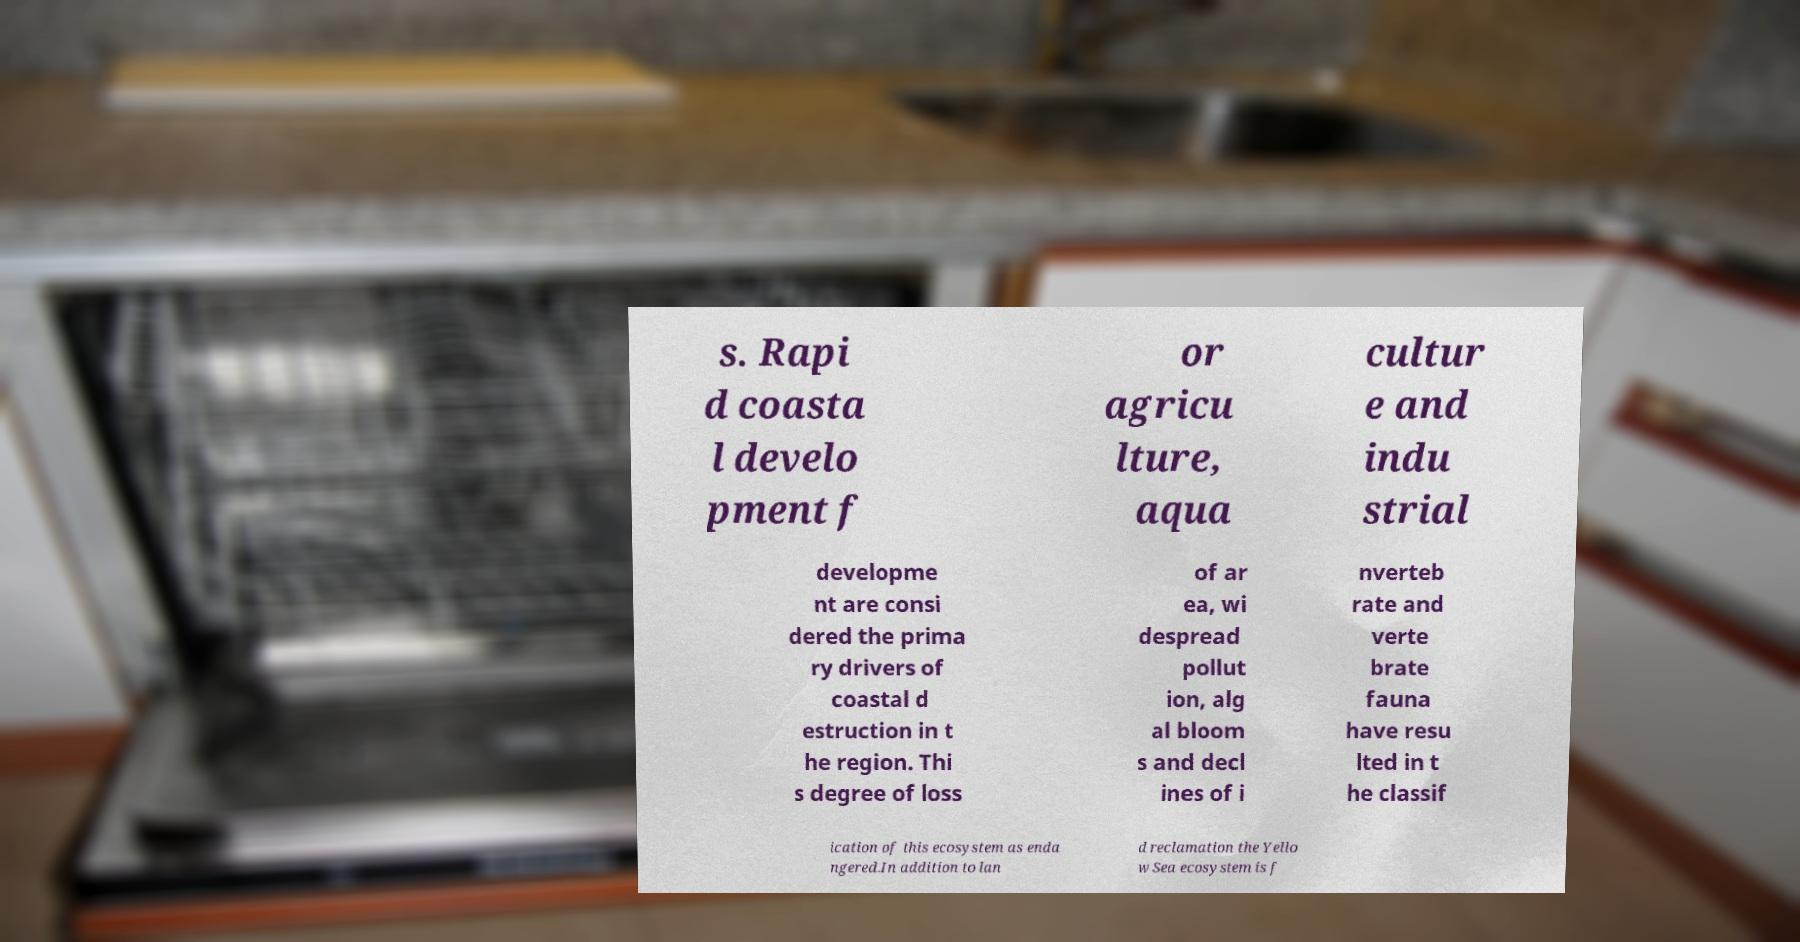What messages or text are displayed in this image? I need them in a readable, typed format. s. Rapi d coasta l develo pment f or agricu lture, aqua cultur e and indu strial developme nt are consi dered the prima ry drivers of coastal d estruction in t he region. Thi s degree of loss of ar ea, wi despread pollut ion, alg al bloom s and decl ines of i nverteb rate and verte brate fauna have resu lted in t he classif ication of this ecosystem as enda ngered.In addition to lan d reclamation the Yello w Sea ecosystem is f 